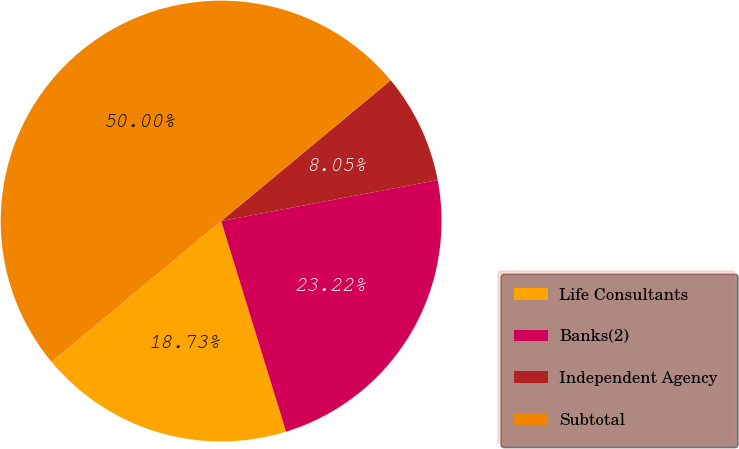Convert chart to OTSL. <chart><loc_0><loc_0><loc_500><loc_500><pie_chart><fcel>Life Consultants<fcel>Banks(2)<fcel>Independent Agency<fcel>Subtotal<nl><fcel>18.73%<fcel>23.22%<fcel>8.05%<fcel>50.0%<nl></chart> 